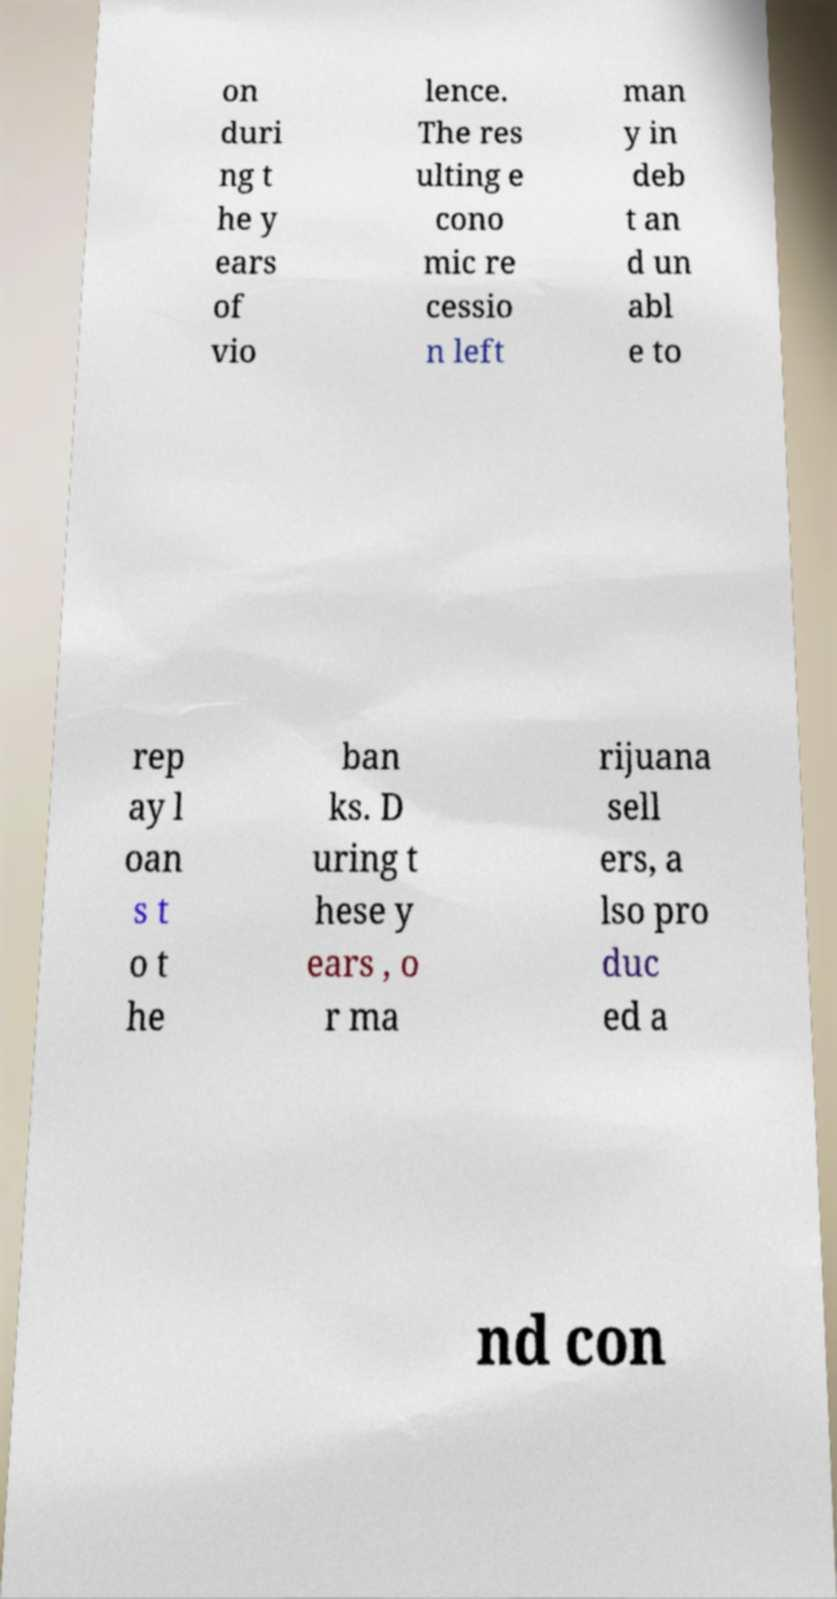Could you extract and type out the text from this image? on duri ng t he y ears of vio lence. The res ulting e cono mic re cessio n left man y in deb t an d un abl e to rep ay l oan s t o t he ban ks. D uring t hese y ears , o r ma rijuana sell ers, a lso pro duc ed a nd con 